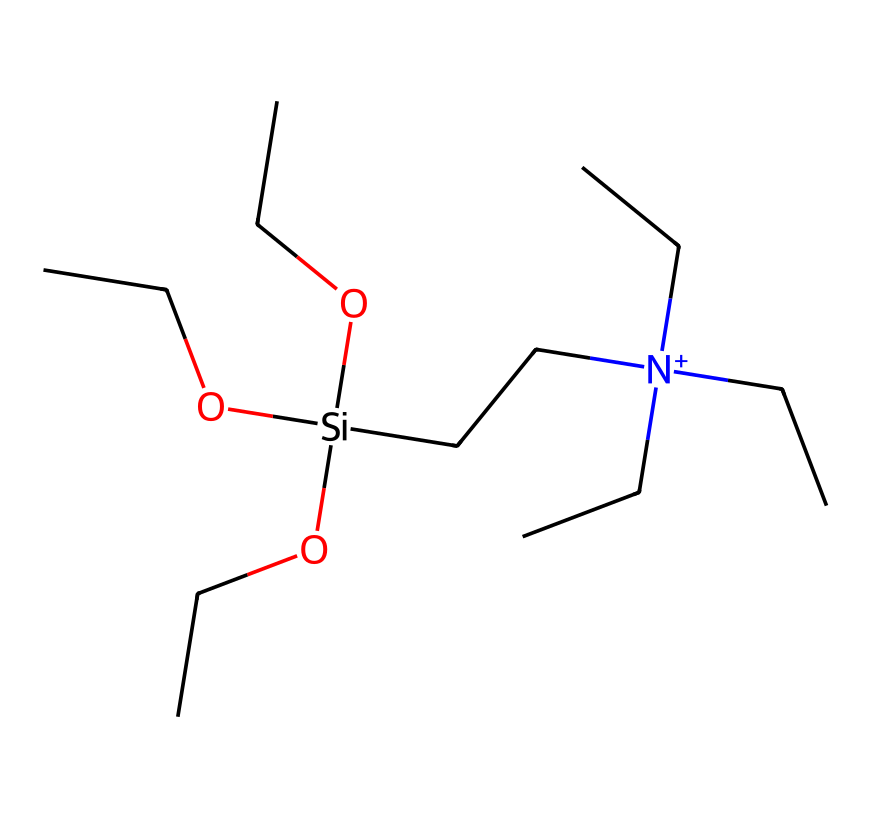how many silicon atoms are present in this structure? The structure provided contains one silicon atom, which can be identified by the symbol "Si" in the SMILES notation.
Answer: one what is the overall charge of this chemical? The notation "[N+]" indicates that there is a positively charged nitrogen atom, making the molecule cationic.
Answer: positive how many ethoxy groups are attached to the silicon atom? Reading the SMILES, there are three "OCC" groups attached to the silicon atom "[Si]", indicating three ethoxy groups.
Answer: three what type of chemical is this cleaning agent? The presence of a silicon atom combined with functional groups like ethoxy suggests that this compound is a silane.
Answer: silane which functional group contributes to the cleaning properties of this silane? The ethoxy groups ("OCC") provide solubility and bonding capacity to surfaces, enhancing cleaning efficacy.
Answer: ethoxy groups how many total carbon atoms are present in this molecule? Counting the carbon atoms in the four ethoxy groups (2 carbons each) gives a total of 8 from them, plus 3 attached to the nitrogen, resulting in 11 carbon atoms in total.
Answer: eleven 